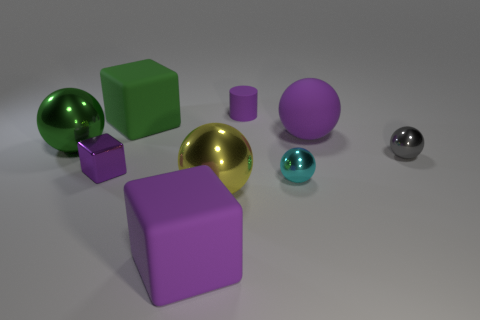Subtract all large matte balls. How many balls are left? 4 Subtract all green cylinders. How many purple cubes are left? 2 Subtract all cyan spheres. How many spheres are left? 4 Subtract all cyan cubes. Subtract all brown cylinders. How many cubes are left? 3 Subtract all small purple matte balls. Subtract all big yellow shiny balls. How many objects are left? 8 Add 2 cubes. How many cubes are left? 5 Add 9 yellow balls. How many yellow balls exist? 10 Subtract 0 green cylinders. How many objects are left? 9 Subtract all spheres. How many objects are left? 4 